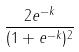Convert formula to latex. <formula><loc_0><loc_0><loc_500><loc_500>\frac { 2 e ^ { - k } } { ( 1 + e ^ { - k } ) ^ { 2 } }</formula> 